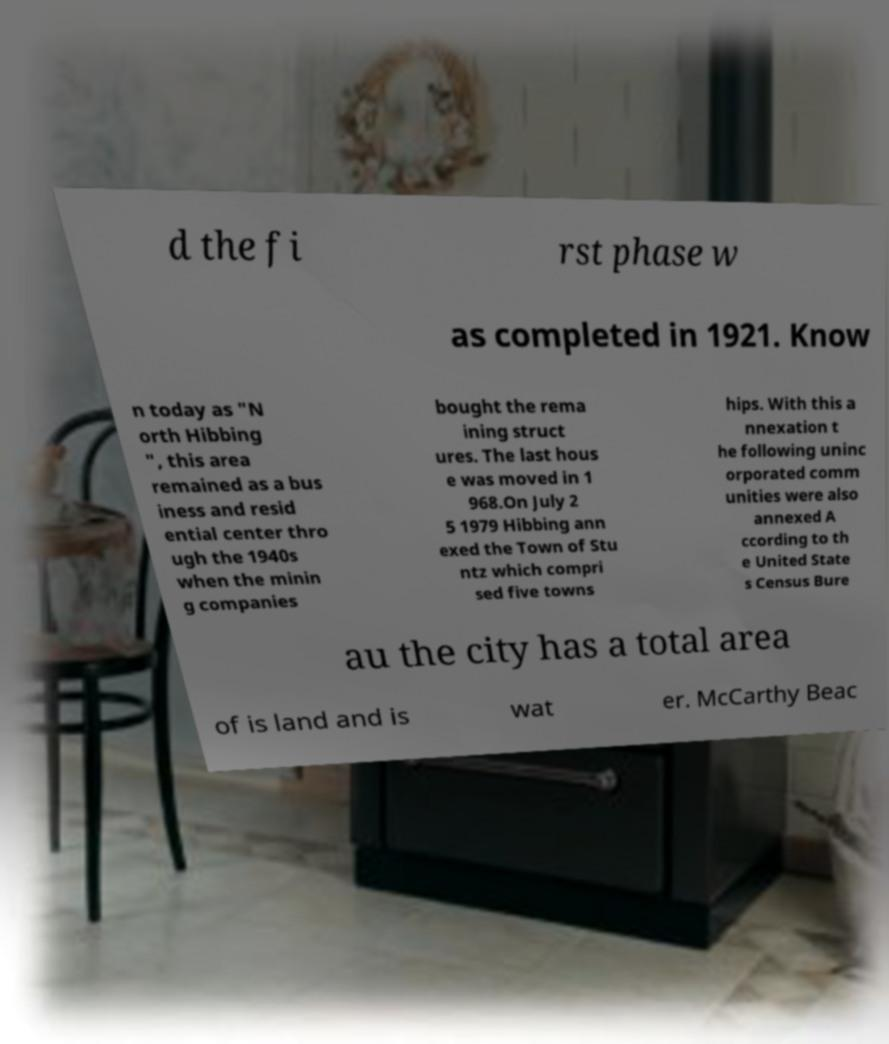I need the written content from this picture converted into text. Can you do that? d the fi rst phase w as completed in 1921. Know n today as "N orth Hibbing ", this area remained as a bus iness and resid ential center thro ugh the 1940s when the minin g companies bought the rema ining struct ures. The last hous e was moved in 1 968.On July 2 5 1979 Hibbing ann exed the Town of Stu ntz which compri sed five towns hips. With this a nnexation t he following uninc orporated comm unities were also annexed A ccording to th e United State s Census Bure au the city has a total area of is land and is wat er. McCarthy Beac 